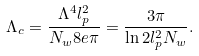<formula> <loc_0><loc_0><loc_500><loc_500>\Lambda _ { c } = \frac { \Lambda ^ { 4 } l _ { p } ^ { 2 } } { N _ { w } 8 e \pi } = \frac { 3 \pi } { \ln 2 l _ { p } ^ { 2 } N _ { w } } .</formula> 